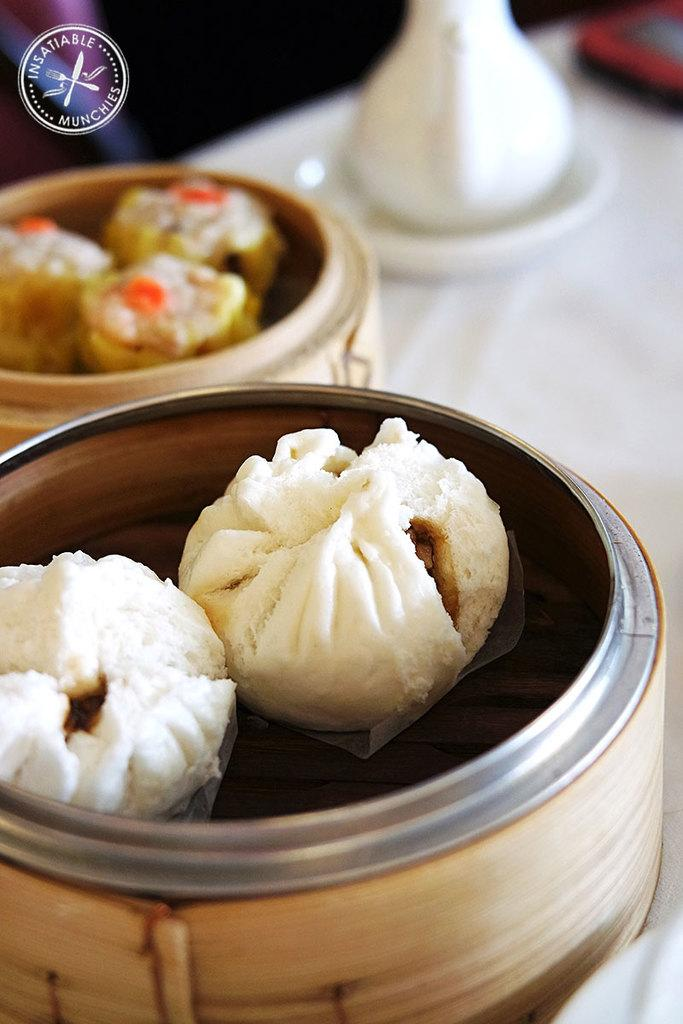<image>
Describe the image concisely. Food on a table with an insatiable munchies watermark in the corner. 